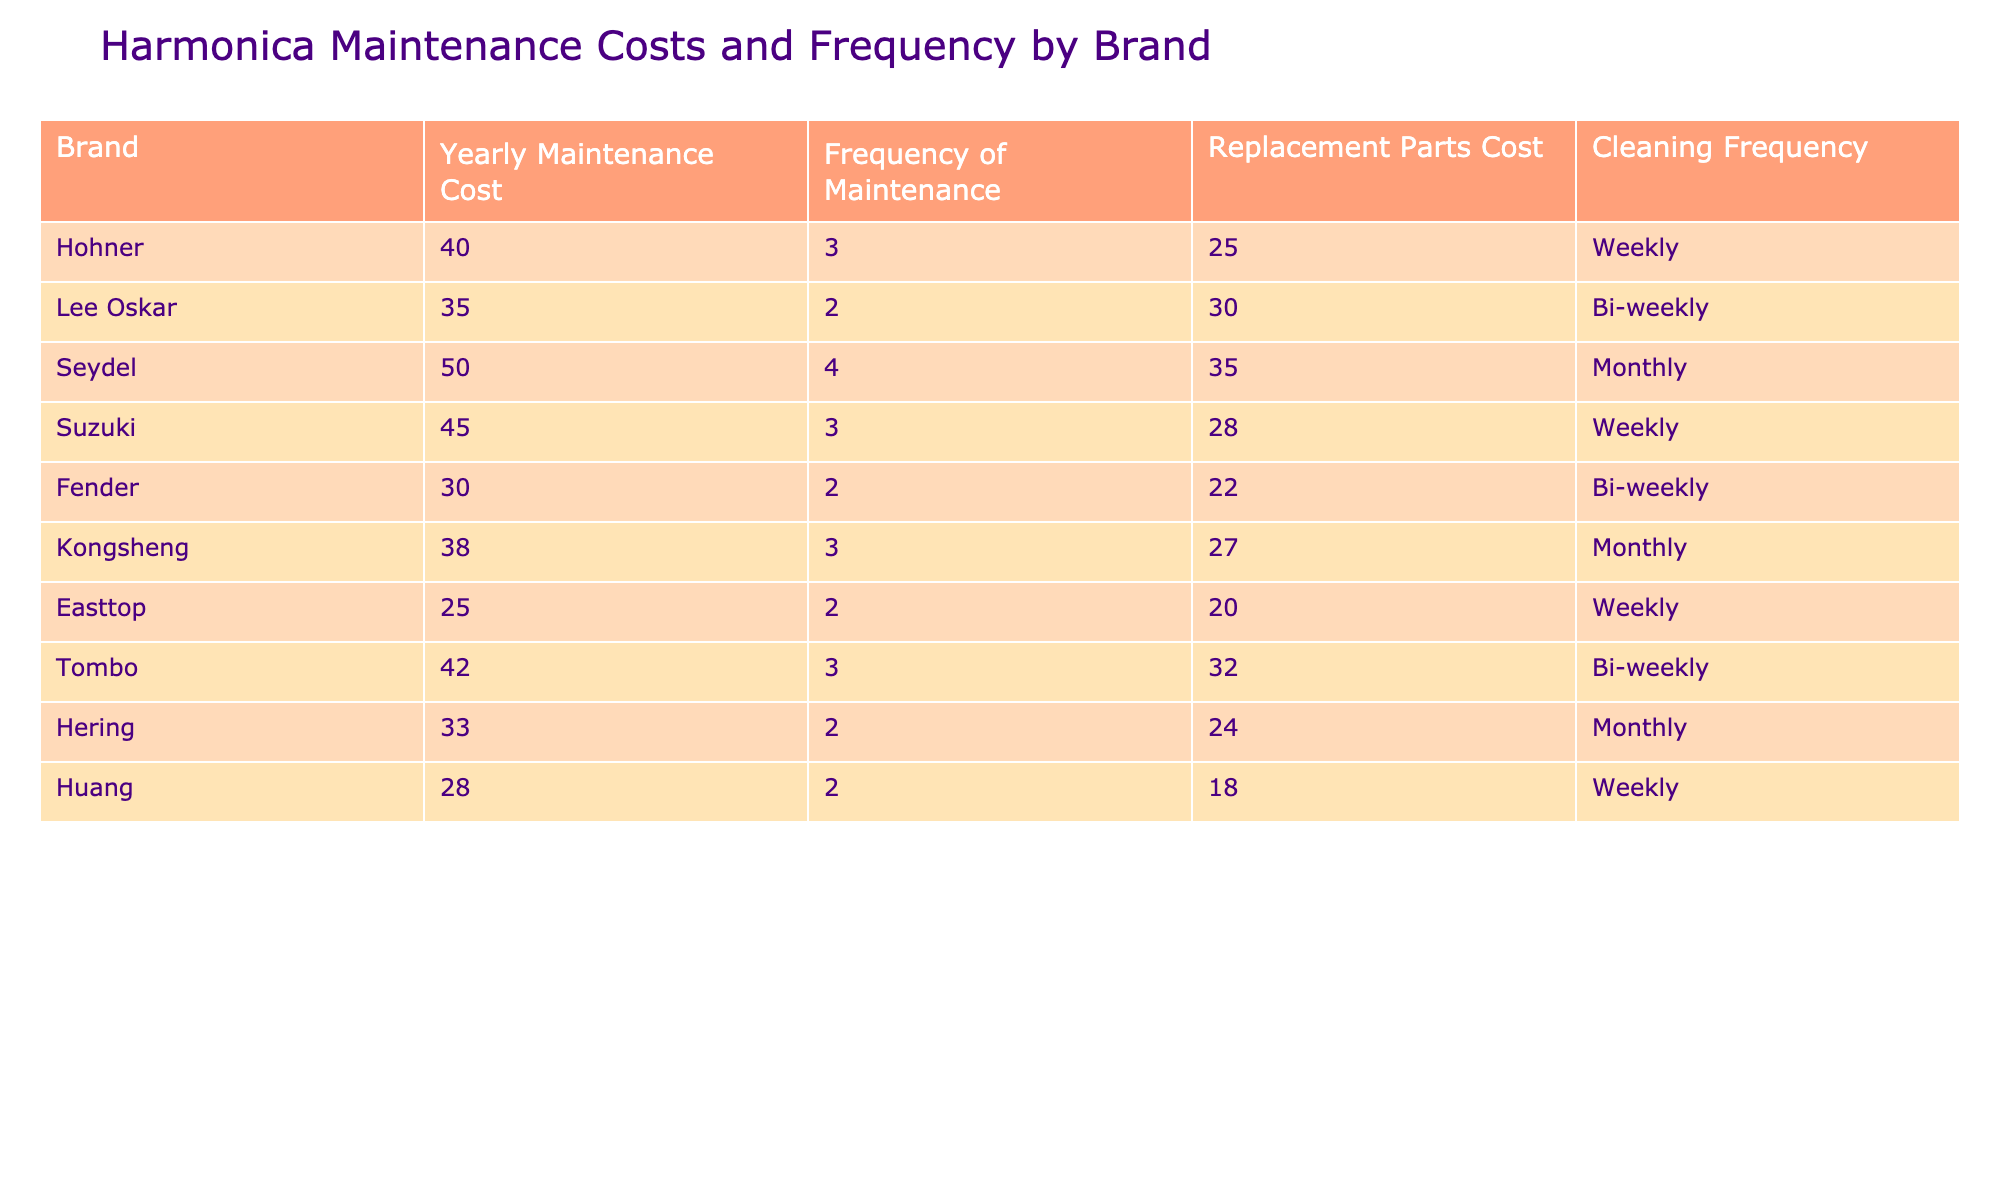What is the yearly maintenance cost for Hohner? The table shows that the yearly maintenance cost for the Hohner brand is $40.
Answer: $40 Which brand has the highest frequency of maintenance? The frequency of maintenance for Seydel is 4 times per year, which is the highest compared to other brands.
Answer: Seydel What is the average replacement parts cost for all brands? The total replacement parts cost is (25 + 30 + 35 + 28 + 22 + 27 + 20 + 32 + 24 + 18) =  3, so we divide by the number of brands (10), which gives us 26.
Answer: $26 Is the cleaning frequency for Lee Oskar weekly? According to the table, the cleaning frequency for Lee Oskar is bi-weekly, so the statement is false.
Answer: No What is the total yearly maintenance cost for all brands combined? To find the total yearly maintenance cost, we add up all the costs (40 + 35 + 50 + 45 + 30 + 38 + 25 + 42 + 33 + 28) =  3. The total is $393.
Answer: $393 Which brand has the lowest yearly maintenance cost and what is it? By comparing yearly maintenance costs, Easttop has the lowest at $25.
Answer: Easttop, $25 How much does Kongsheng spend on maintenance costs compared to Fender? Kongsheng's yearly maintenance cost is $38, while Fender's is $30. The difference is $38 - $30 = $8, meaning Kongsheng spends $8 more.
Answer: $8 more Do any brands have a cleaning frequency of monthly? Yes, Seydel and Kongsheng have a cleaning frequency of monthly.
Answer: Yes If we look at the brands that clean their harmonicas weekly, what is their average yearly maintenance cost? The brands that clean weekly are Hohner, Suzuki, and Easttop. Their yearly maintenance costs are $40, $45, and $25. The average is (40 + 45 + 25) / 3 = 36.67, which rounds to $37.
Answer: $37 Which brand has both the highest replacement parts cost and the highest frequency of maintenance? Seydel has a replacement parts cost of $35 and a frequency of 4, which are the highest in their respective categories.
Answer: Seydel 